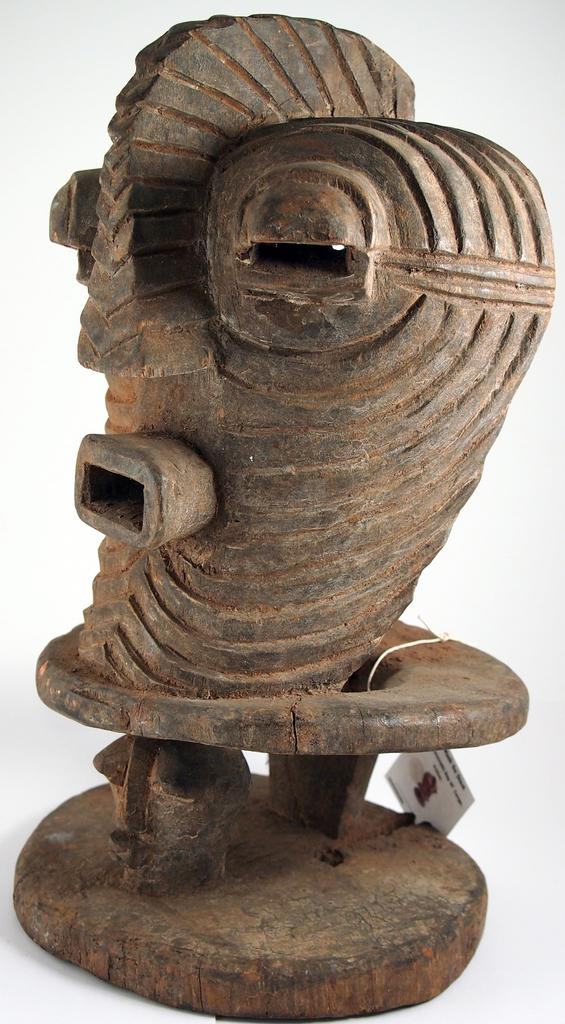What is the main subject of the image? There is a sculpture in the image. Is there anything attached to the sculpture? Yes, there is a card tied to the sculpture. What can be found on the card? The card has text and a picture on it. What is the color of the background in the image? The background of the image is white. How many ships can be seen sailing in the background of the image? There are no ships visible in the image; the background is white. Are there any wheels or bikes present in the image? No, there are no wheels or bikes present in the image. 